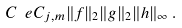Convert formula to latex. <formula><loc_0><loc_0><loc_500><loc_500>C _ { \ } e C _ { j , m } \| f \| _ { 2 } \| g \| _ { 2 } \| h \| _ { \infty } \, .</formula> 